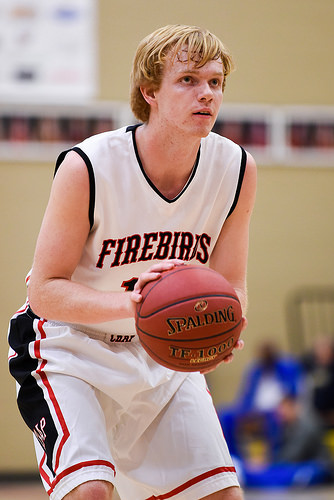<image>
Can you confirm if the ball is next to the kid? No. The ball is not positioned next to the kid. They are located in different areas of the scene. 